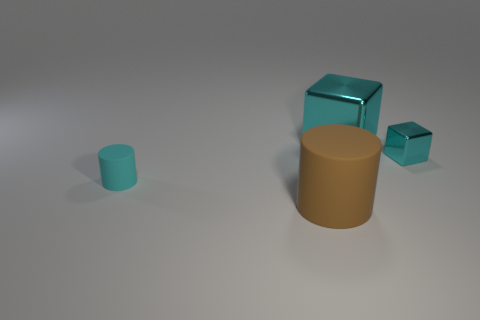Add 2 large cyan metallic things. How many objects exist? 6 Add 2 cyan rubber cylinders. How many cyan rubber cylinders are left? 3 Add 1 tiny shiny objects. How many tiny shiny objects exist? 2 Subtract 0 gray spheres. How many objects are left? 4 Subtract all brown objects. Subtract all small cyan metallic cubes. How many objects are left? 2 